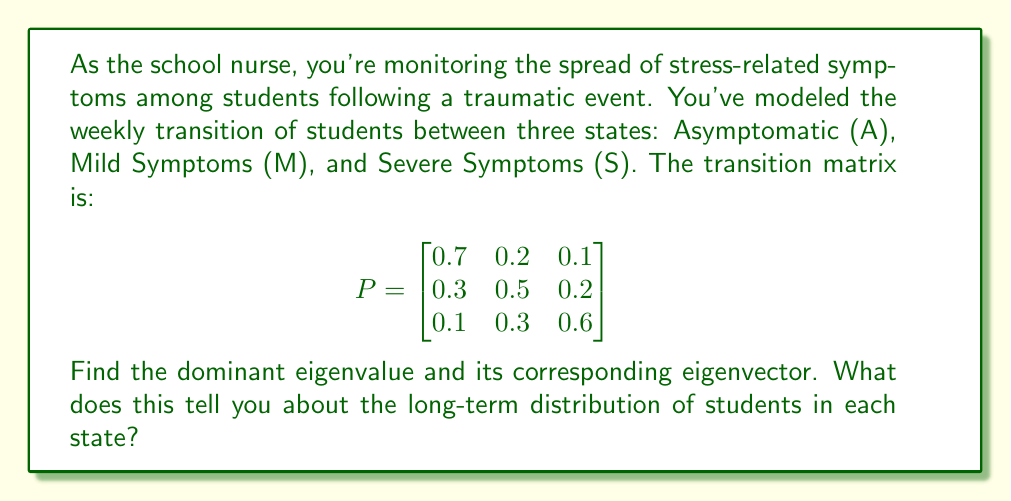Solve this math problem. To solve this problem, we'll follow these steps:

1) Find the characteristic equation:
   $$det(P - \lambda I) = 0$$
   
   $$\begin{vmatrix}
   0.7-\lambda & 0.2 & 0.1 \\
   0.3 & 0.5-\lambda & 0.2 \\
   0.1 & 0.3 & 0.6-\lambda
   \end{vmatrix} = 0$$

2) Expand the determinant:
   $$(0.7-\lambda)[(0.5-\lambda)(0.6-\lambda)-0.06] - 0.2[0.3(0.6-\lambda)-0.02] + 0.1[0.3(0.5-\lambda)-0.06] = 0$$

3) Simplify:
   $$-\lambda^3 + 1.8\lambda^2 - 0.83\lambda + 0.1 = 0$$

4) Solve this cubic equation. The solutions are the eigenvalues. The largest eigenvalue is the dominant one:
   $$\lambda_1 = 1, \lambda_2 \approx 0.5229, \lambda_3 \approx 0.2771$$

5) For the dominant eigenvalue $\lambda_1 = 1$, find the corresponding eigenvector $\vec{v}$ by solving:
   $$(P - I)\vec{v} = \vec{0}$$

   $$\begin{bmatrix}
   -0.3 & 0.2 & 0.1 \\
   0.3 & -0.5 & 0.2 \\
   0.1 & 0.3 & -0.4
   \end{bmatrix}\begin{bmatrix}
   v_1 \\ v_2 \\ v_3
   \end{bmatrix} = \begin{bmatrix}
   0 \\ 0 \\ 0
   \end{bmatrix}$$

6) Solve this system of equations. One solution is:
   $$\vec{v} = \begin{bmatrix}
   5 \\ 3 \\ 2
   \end{bmatrix}$$

7) Normalize this vector to get the long-term distribution:
   $$\frac{\vec{v}}{\sum v_i} = \begin{bmatrix}
   0.5 \\ 0.3 \\ 0.2
   \end{bmatrix}$$

This eigenvector represents the stable state distribution. In the long term, regardless of the initial distribution, 50% of students will be Asymptomatic, 30% will have Mild Symptoms, and 20% will have Severe Symptoms.
Answer: The dominant eigenvalue is 1, and its corresponding normalized eigenvector is $[0.5, 0.3, 0.2]^T$. This indicates that in the long term, 50% of students will be Asymptomatic, 30% will have Mild Symptoms, and 20% will have Severe Symptoms, regardless of the initial distribution. 